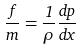Convert formula to latex. <formula><loc_0><loc_0><loc_500><loc_500>\frac { f } { m } = \frac { 1 } { \rho } \frac { d p } { d x }</formula> 